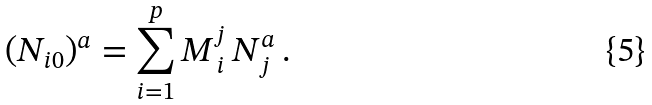<formula> <loc_0><loc_0><loc_500><loc_500>( N _ { i 0 } ) ^ { a } = \sum _ { i = 1 } ^ { p } M ^ { j } _ { \, i } \, N _ { j } ^ { a } \, .</formula> 